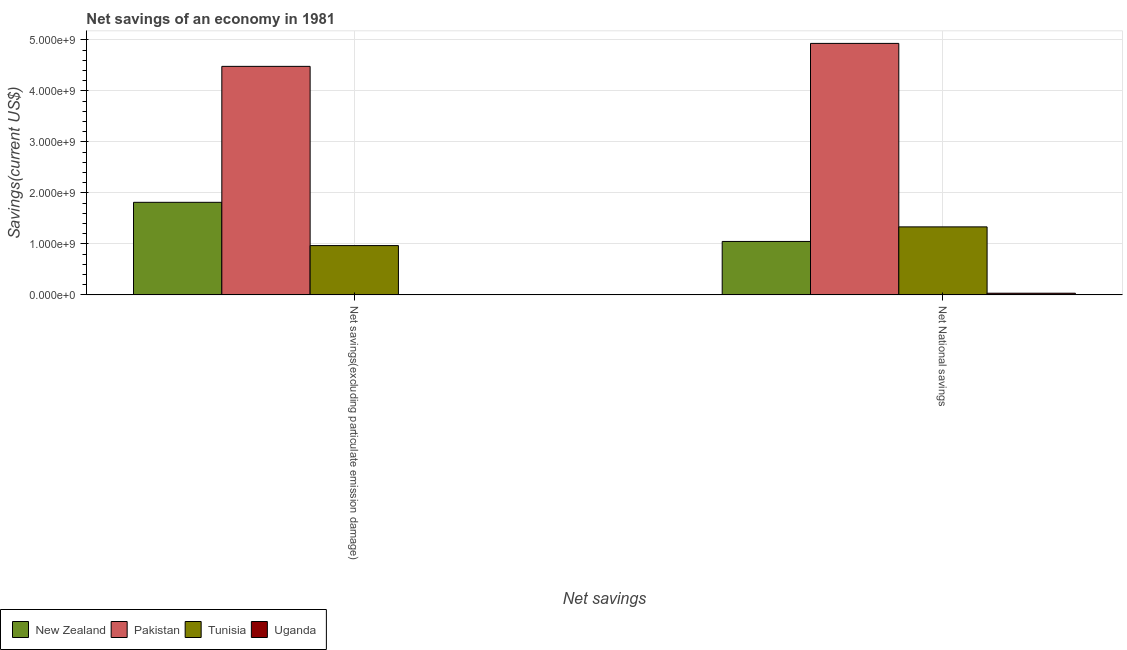How many different coloured bars are there?
Provide a short and direct response. 4. How many groups of bars are there?
Your answer should be very brief. 2. Are the number of bars per tick equal to the number of legend labels?
Make the answer very short. No. How many bars are there on the 1st tick from the left?
Your answer should be compact. 3. How many bars are there on the 1st tick from the right?
Give a very brief answer. 4. What is the label of the 1st group of bars from the left?
Your answer should be very brief. Net savings(excluding particulate emission damage). What is the net savings(excluding particulate emission damage) in New Zealand?
Provide a short and direct response. 1.82e+09. Across all countries, what is the maximum net savings(excluding particulate emission damage)?
Keep it short and to the point. 4.48e+09. Across all countries, what is the minimum net national savings?
Ensure brevity in your answer.  3.29e+07. In which country was the net savings(excluding particulate emission damage) maximum?
Ensure brevity in your answer.  Pakistan. What is the total net savings(excluding particulate emission damage) in the graph?
Your answer should be very brief. 7.26e+09. What is the difference between the net national savings in Uganda and that in Tunisia?
Offer a very short reply. -1.30e+09. What is the difference between the net savings(excluding particulate emission damage) in Uganda and the net national savings in Tunisia?
Your response must be concise. -1.33e+09. What is the average net national savings per country?
Offer a very short reply. 1.84e+09. What is the difference between the net national savings and net savings(excluding particulate emission damage) in New Zealand?
Your answer should be very brief. -7.67e+08. What is the ratio of the net national savings in New Zealand to that in Pakistan?
Ensure brevity in your answer.  0.21. Is the net savings(excluding particulate emission damage) in New Zealand less than that in Tunisia?
Provide a short and direct response. No. How many bars are there?
Make the answer very short. 7. What is the difference between two consecutive major ticks on the Y-axis?
Keep it short and to the point. 1.00e+09. Are the values on the major ticks of Y-axis written in scientific E-notation?
Your answer should be very brief. Yes. Does the graph contain any zero values?
Keep it short and to the point. Yes. Does the graph contain grids?
Make the answer very short. Yes. Where does the legend appear in the graph?
Your answer should be compact. Bottom left. How many legend labels are there?
Offer a terse response. 4. How are the legend labels stacked?
Ensure brevity in your answer.  Horizontal. What is the title of the graph?
Ensure brevity in your answer.  Net savings of an economy in 1981. What is the label or title of the X-axis?
Make the answer very short. Net savings. What is the label or title of the Y-axis?
Provide a succinct answer. Savings(current US$). What is the Savings(current US$) of New Zealand in Net savings(excluding particulate emission damage)?
Make the answer very short. 1.82e+09. What is the Savings(current US$) in Pakistan in Net savings(excluding particulate emission damage)?
Keep it short and to the point. 4.48e+09. What is the Savings(current US$) in Tunisia in Net savings(excluding particulate emission damage)?
Offer a terse response. 9.67e+08. What is the Savings(current US$) in Uganda in Net savings(excluding particulate emission damage)?
Ensure brevity in your answer.  0. What is the Savings(current US$) of New Zealand in Net National savings?
Your response must be concise. 1.05e+09. What is the Savings(current US$) of Pakistan in Net National savings?
Provide a succinct answer. 4.93e+09. What is the Savings(current US$) in Tunisia in Net National savings?
Your answer should be very brief. 1.33e+09. What is the Savings(current US$) of Uganda in Net National savings?
Your answer should be very brief. 3.29e+07. Across all Net savings, what is the maximum Savings(current US$) of New Zealand?
Your response must be concise. 1.82e+09. Across all Net savings, what is the maximum Savings(current US$) of Pakistan?
Offer a terse response. 4.93e+09. Across all Net savings, what is the maximum Savings(current US$) in Tunisia?
Ensure brevity in your answer.  1.33e+09. Across all Net savings, what is the maximum Savings(current US$) in Uganda?
Your response must be concise. 3.29e+07. Across all Net savings, what is the minimum Savings(current US$) of New Zealand?
Provide a succinct answer. 1.05e+09. Across all Net savings, what is the minimum Savings(current US$) of Pakistan?
Offer a terse response. 4.48e+09. Across all Net savings, what is the minimum Savings(current US$) of Tunisia?
Provide a succinct answer. 9.67e+08. What is the total Savings(current US$) in New Zealand in the graph?
Your response must be concise. 2.86e+09. What is the total Savings(current US$) of Pakistan in the graph?
Provide a succinct answer. 9.42e+09. What is the total Savings(current US$) of Tunisia in the graph?
Make the answer very short. 2.30e+09. What is the total Savings(current US$) in Uganda in the graph?
Offer a very short reply. 3.29e+07. What is the difference between the Savings(current US$) in New Zealand in Net savings(excluding particulate emission damage) and that in Net National savings?
Offer a terse response. 7.67e+08. What is the difference between the Savings(current US$) in Pakistan in Net savings(excluding particulate emission damage) and that in Net National savings?
Ensure brevity in your answer.  -4.51e+08. What is the difference between the Savings(current US$) of Tunisia in Net savings(excluding particulate emission damage) and that in Net National savings?
Offer a very short reply. -3.67e+08. What is the difference between the Savings(current US$) in New Zealand in Net savings(excluding particulate emission damage) and the Savings(current US$) in Pakistan in Net National savings?
Make the answer very short. -3.12e+09. What is the difference between the Savings(current US$) of New Zealand in Net savings(excluding particulate emission damage) and the Savings(current US$) of Tunisia in Net National savings?
Ensure brevity in your answer.  4.82e+08. What is the difference between the Savings(current US$) in New Zealand in Net savings(excluding particulate emission damage) and the Savings(current US$) in Uganda in Net National savings?
Make the answer very short. 1.78e+09. What is the difference between the Savings(current US$) of Pakistan in Net savings(excluding particulate emission damage) and the Savings(current US$) of Tunisia in Net National savings?
Your answer should be very brief. 3.15e+09. What is the difference between the Savings(current US$) in Pakistan in Net savings(excluding particulate emission damage) and the Savings(current US$) in Uganda in Net National savings?
Provide a short and direct response. 4.45e+09. What is the difference between the Savings(current US$) in Tunisia in Net savings(excluding particulate emission damage) and the Savings(current US$) in Uganda in Net National savings?
Offer a very short reply. 9.34e+08. What is the average Savings(current US$) in New Zealand per Net savings?
Your answer should be compact. 1.43e+09. What is the average Savings(current US$) in Pakistan per Net savings?
Provide a short and direct response. 4.71e+09. What is the average Savings(current US$) of Tunisia per Net savings?
Give a very brief answer. 1.15e+09. What is the average Savings(current US$) of Uganda per Net savings?
Make the answer very short. 1.64e+07. What is the difference between the Savings(current US$) of New Zealand and Savings(current US$) of Pakistan in Net savings(excluding particulate emission damage)?
Your answer should be compact. -2.67e+09. What is the difference between the Savings(current US$) of New Zealand and Savings(current US$) of Tunisia in Net savings(excluding particulate emission damage)?
Provide a succinct answer. 8.49e+08. What is the difference between the Savings(current US$) in Pakistan and Savings(current US$) in Tunisia in Net savings(excluding particulate emission damage)?
Give a very brief answer. 3.52e+09. What is the difference between the Savings(current US$) in New Zealand and Savings(current US$) in Pakistan in Net National savings?
Your answer should be compact. -3.88e+09. What is the difference between the Savings(current US$) of New Zealand and Savings(current US$) of Tunisia in Net National savings?
Your answer should be very brief. -2.86e+08. What is the difference between the Savings(current US$) of New Zealand and Savings(current US$) of Uganda in Net National savings?
Provide a succinct answer. 1.02e+09. What is the difference between the Savings(current US$) of Pakistan and Savings(current US$) of Tunisia in Net National savings?
Your answer should be compact. 3.60e+09. What is the difference between the Savings(current US$) in Pakistan and Savings(current US$) in Uganda in Net National savings?
Give a very brief answer. 4.90e+09. What is the difference between the Savings(current US$) in Tunisia and Savings(current US$) in Uganda in Net National savings?
Give a very brief answer. 1.30e+09. What is the ratio of the Savings(current US$) in New Zealand in Net savings(excluding particulate emission damage) to that in Net National savings?
Your response must be concise. 1.73. What is the ratio of the Savings(current US$) of Pakistan in Net savings(excluding particulate emission damage) to that in Net National savings?
Provide a short and direct response. 0.91. What is the ratio of the Savings(current US$) of Tunisia in Net savings(excluding particulate emission damage) to that in Net National savings?
Keep it short and to the point. 0.72. What is the difference between the highest and the second highest Savings(current US$) in New Zealand?
Offer a terse response. 7.67e+08. What is the difference between the highest and the second highest Savings(current US$) in Pakistan?
Your answer should be very brief. 4.51e+08. What is the difference between the highest and the second highest Savings(current US$) of Tunisia?
Ensure brevity in your answer.  3.67e+08. What is the difference between the highest and the lowest Savings(current US$) in New Zealand?
Give a very brief answer. 7.67e+08. What is the difference between the highest and the lowest Savings(current US$) in Pakistan?
Your answer should be compact. 4.51e+08. What is the difference between the highest and the lowest Savings(current US$) in Tunisia?
Your answer should be compact. 3.67e+08. What is the difference between the highest and the lowest Savings(current US$) of Uganda?
Keep it short and to the point. 3.29e+07. 